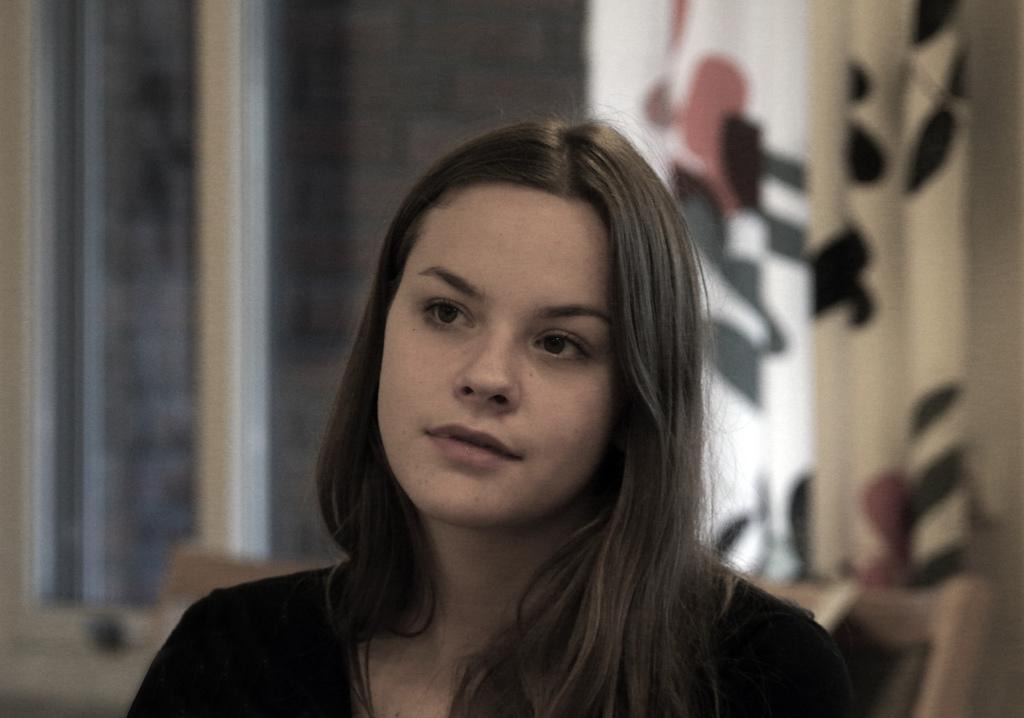How would you summarize this image in a sentence or two? In this image in the foreground there is one woman, and in the background there are windows and curtains. 